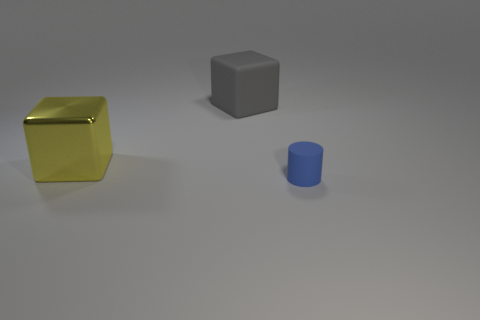How many yellow metallic objects are there? 1 